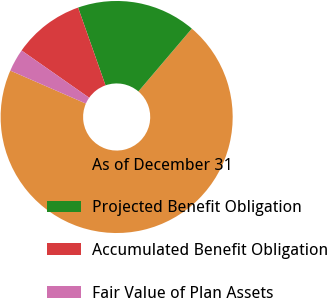Convert chart to OTSL. <chart><loc_0><loc_0><loc_500><loc_500><pie_chart><fcel>As of December 31<fcel>Projected Benefit Obligation<fcel>Accumulated Benefit Obligation<fcel>Fair Value of Plan Assets<nl><fcel>70.33%<fcel>16.61%<fcel>9.89%<fcel>3.17%<nl></chart> 